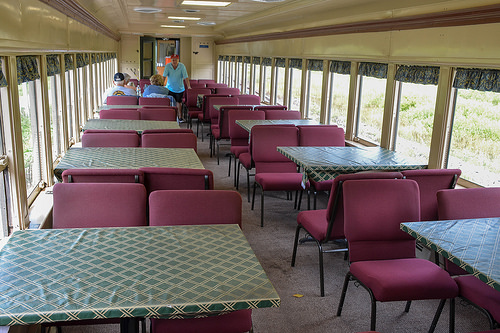<image>
Is the man on the chair? No. The man is not positioned on the chair. They may be near each other, but the man is not supported by or resting on top of the chair. Is the floor under the man? Yes. The floor is positioned underneath the man, with the man above it in the vertical space. 